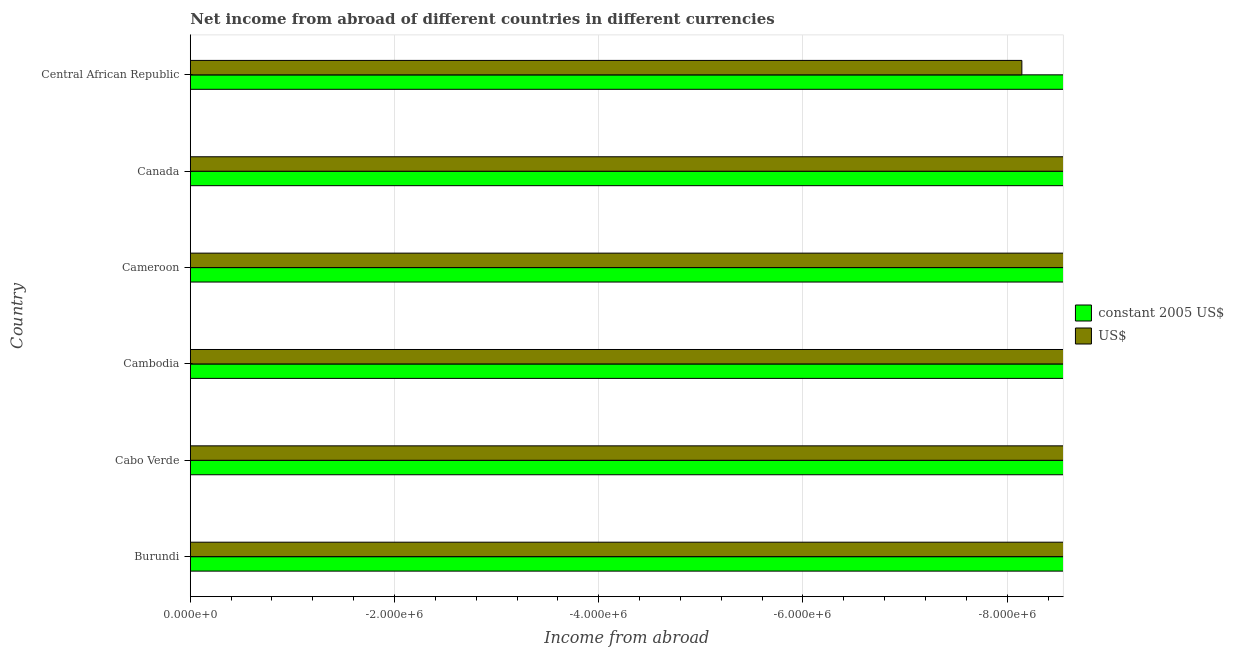Are the number of bars on each tick of the Y-axis equal?
Keep it short and to the point. Yes. How many bars are there on the 4th tick from the top?
Make the answer very short. 0. How many bars are there on the 2nd tick from the bottom?
Your answer should be very brief. 0. What is the label of the 4th group of bars from the top?
Make the answer very short. Cambodia. Across all countries, what is the minimum income from abroad in constant 2005 us$?
Offer a terse response. 0. What is the total income from abroad in constant 2005 us$ in the graph?
Offer a terse response. 0. What is the difference between the income from abroad in constant 2005 us$ in Cameroon and the income from abroad in us$ in Cabo Verde?
Make the answer very short. 0. How many bars are there?
Give a very brief answer. 0. How many countries are there in the graph?
Provide a short and direct response. 6. Does the graph contain any zero values?
Offer a very short reply. Yes. Does the graph contain grids?
Offer a terse response. Yes. How many legend labels are there?
Make the answer very short. 2. How are the legend labels stacked?
Keep it short and to the point. Vertical. What is the title of the graph?
Provide a succinct answer. Net income from abroad of different countries in different currencies. Does "Total Population" appear as one of the legend labels in the graph?
Provide a succinct answer. No. What is the label or title of the X-axis?
Offer a very short reply. Income from abroad. What is the Income from abroad in US$ in Cabo Verde?
Give a very brief answer. 0. What is the Income from abroad in constant 2005 US$ in Cambodia?
Your answer should be very brief. 0. What is the Income from abroad in constant 2005 US$ in Cameroon?
Ensure brevity in your answer.  0. What is the Income from abroad of US$ in Cameroon?
Give a very brief answer. 0. What is the Income from abroad of US$ in Central African Republic?
Provide a succinct answer. 0. 